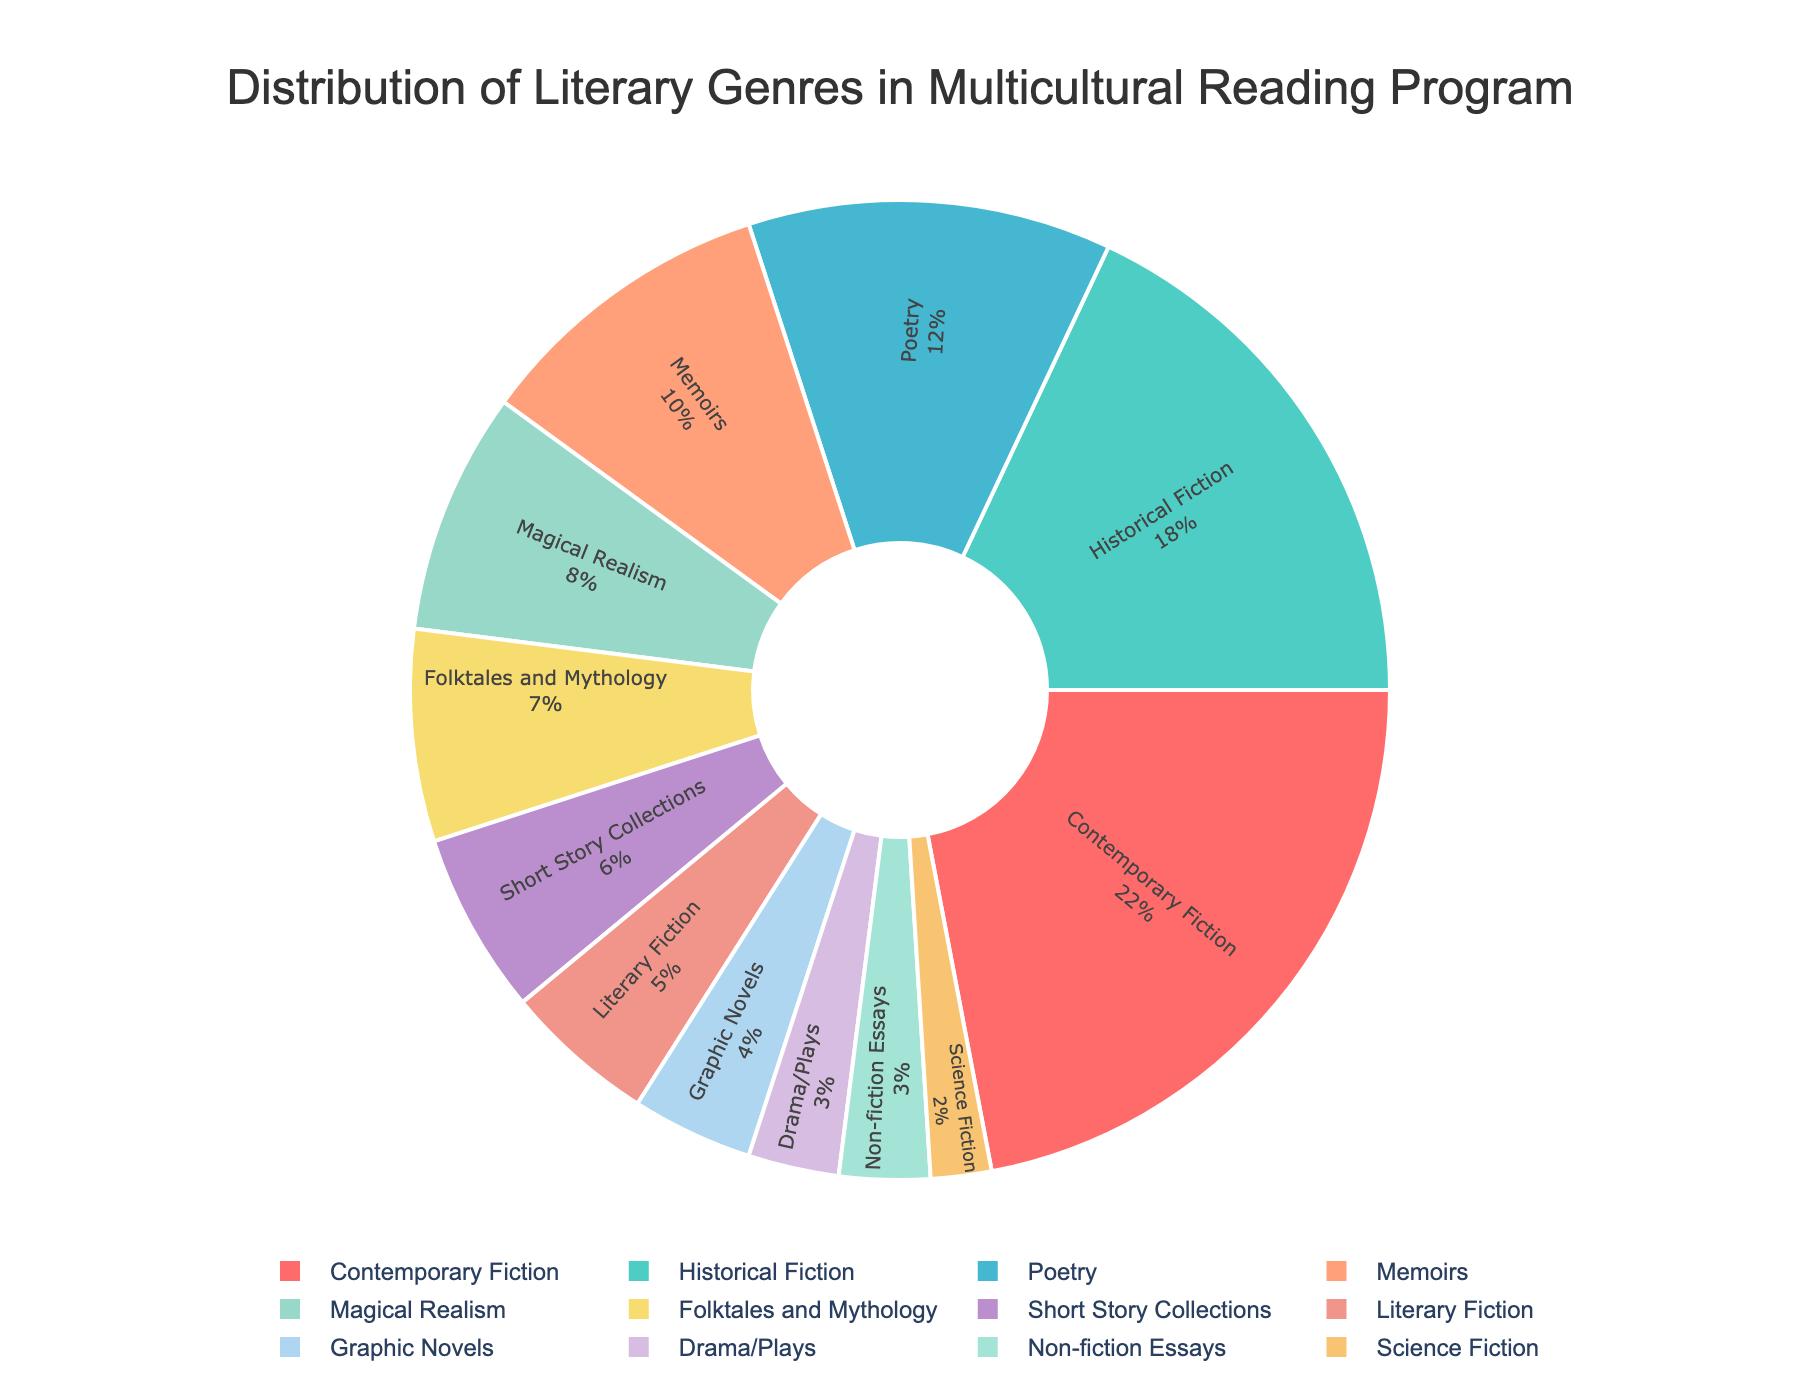What's the total percentage of Contemporary Fiction and Historical Fiction combined? To find the total percentage of Contemporary Fiction and Historical Fiction, add their percentages together: 22% (Contemporary Fiction) + 18% (Historical Fiction) = 40%
Answer: 40% Which genre has the smallest representation in the multicultural reading program? The genre with the smallest percentage can be identified as having the lowest value. The smallest percentage in the given data is for Science Fiction at 2%
Answer: Science Fiction How much more popular is Poetry compared to Drama/Plays in percentage points? To find how much more popular Poetry is compared to Drama/Plays, subtract the percentage of Drama/Plays from the percentage of Poetry: 12% (Poetry) - 3% (Drama/Plays) = 9%
Answer: 9% What genres together make up more than half of the multicultural reading program? To see which genres combine to make more than 50%, start from the largest percentages and add them until the sum exceeds 50%. Summing the largest genres: Contemporary Fiction (22%) + Historical Fiction (18%) + Poetry (12%) = 52%
Answer: Contemporary Fiction, Historical Fiction, and Poetry What is the average percentage representation of Memoirs, Graphic Novels, and Science Fiction? To find the average percentage of Memoirs, Graphic Novels, and Science Fiction, sum their percentages and divide by 3: (10% + 4% + 2%) / 3 = 16% / 3 ≈ 5.33%
Answer: 5.33% Compare the representation of Short Story Collections and Literary Fiction. Which genre has a higher representation and by how much? Compare the percentages of Short Story Collections and Literary Fiction: 6% (Short Story Collections) - 5% (Literary Fiction) = 1%. Short Story Collections has a higher representation by 1%
Answer: Short Story Collections by 1% What visual attribute can help identify Memoirs in the pie chart? To identify Memoirs, look for the percentage (10%) and note that the corresponding slice will be colored in one of the distinct chart colors, such as #98D8C8. Specifically, it represents 10% on the pie chart.
Answer: Slice representing 10% How does the combined percentage of the least three represented genres compare to Memoirs? Sum the percentages of the three least represented genres: Drama/Plays (3%) + Non-fiction Essays (3%) + Science Fiction (2%) = 8%. Compare to Memoirs at 10%. Memoirs are more by 2%.
Answer: Memoirs by 2% What color represents Folktales and Mythology in the pie chart? Determine the color tied to the 7% slice, attributed to Folktales and Mythology. Based on the custom palette sequence, Folktales and Mythology would be associated with a specific hue provided in the chart.
Answer: Corresponding color (e.g., #F7DC6F if following the order) 